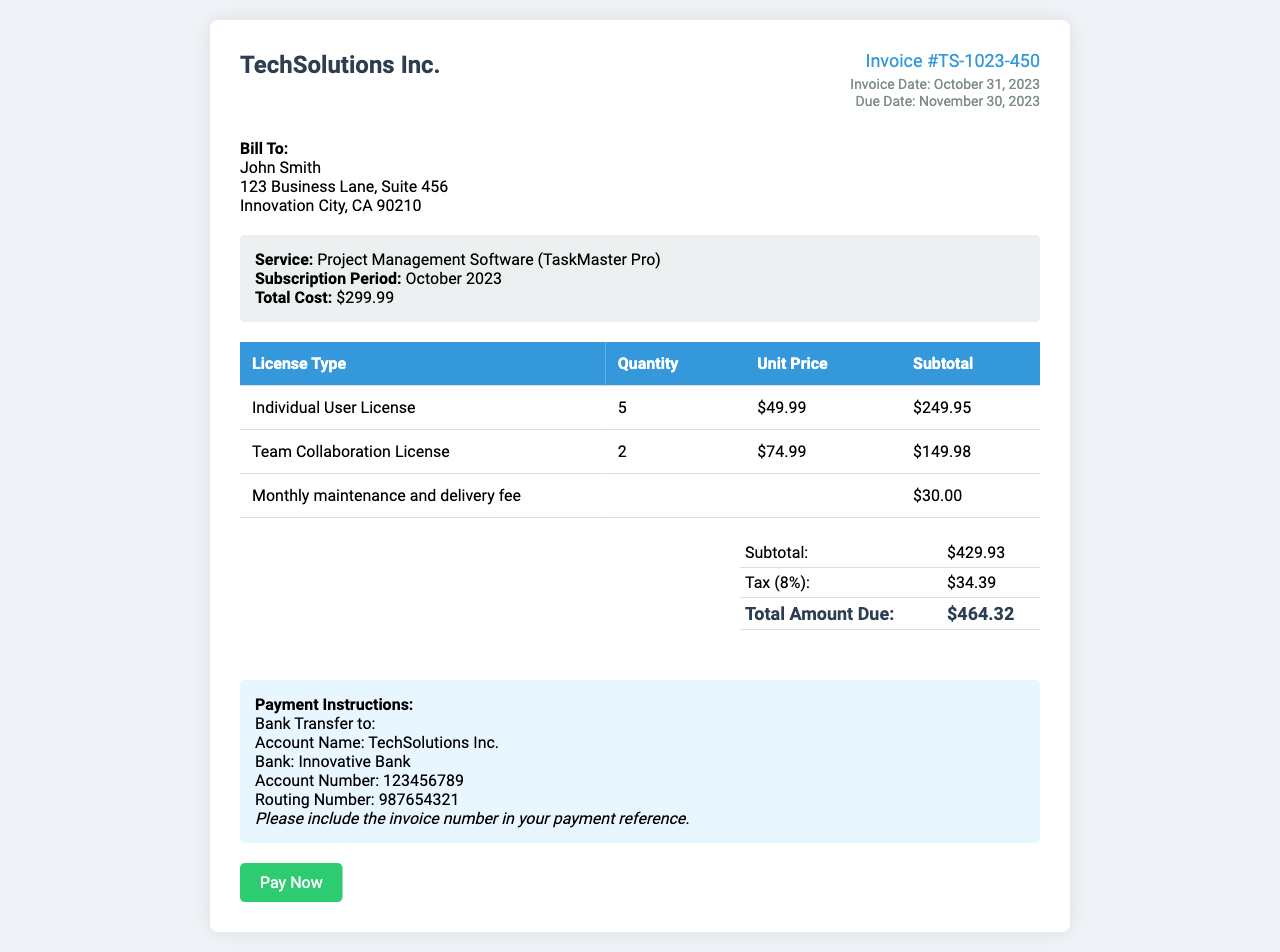What is the invoice number? The invoice number is mentioned in the document as a unique identifier for this invoice: TS-1023-450.
Answer: TS-1023-450 What is the total cost of the subscription? The total cost is explicitly stated in the subscription details as $299.99.
Answer: $299.99 How many Individual User Licenses were purchased? The document specifies that 5 Individual User Licenses were purchased.
Answer: 5 What is the subtotal amount before tax? The subtotal is calculated and presented in the summary section as $429.93.
Answer: $429.93 What is the tax percentage applied? The tax percentage is listed in the summary as 8%.
Answer: 8% What is the amount due on this invoice? The total amount due is stated clearly in the summary section: $464.32.
Answer: $464.32 Which service is billed in this invoice? The service provided is clearly mentioned in the document: Project Management Software (TaskMaster Pro).
Answer: Project Management Software (TaskMaster Pro) What are the payment instructions provided? The payment instructions detail how to transfer the payment to TechSolutions Inc. via bank transfer.
Answer: Bank Transfer to TechSolutions Inc How many Team Collaboration Licenses were included? The document specifies a purchase of 2 Team Collaboration Licenses.
Answer: 2 